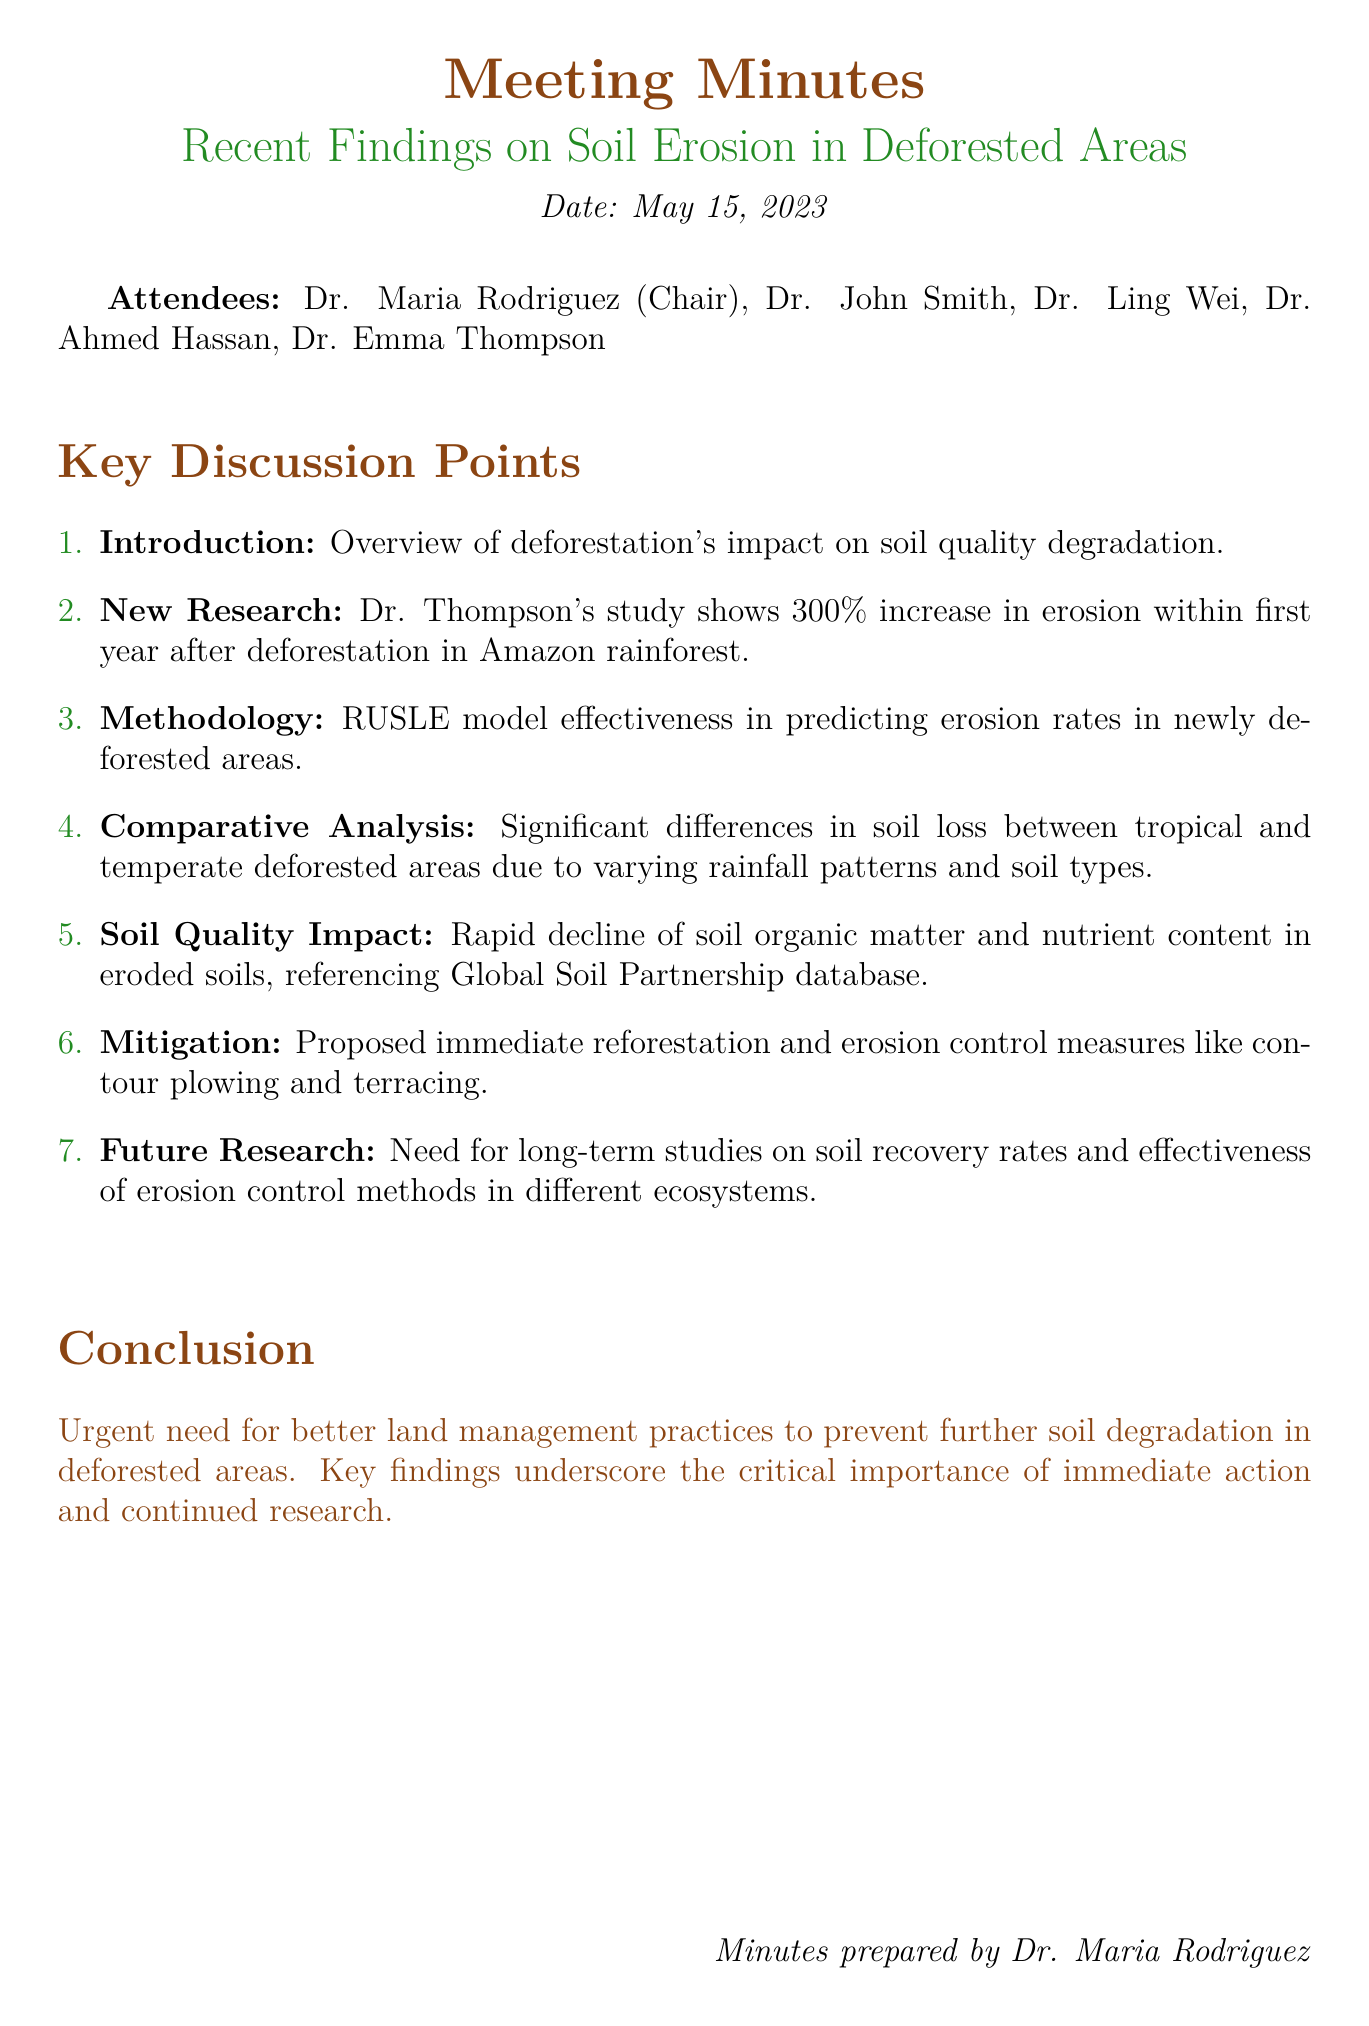What was the date of the meeting? The date of the meeting is clearly stated at the beginning of the document.
Answer: May 15, 2023 Who chaired the meeting? The document lists Dr. Maria Rodriguez as the chair of the meeting.
Answer: Dr. Maria Rodriguez What percentage increase in erosion was observed in the study? The document states that there was a 300% increase in erosion after deforestation.
Answer: 300% What model was discussed for predicting erosion rates? The RUSLE model is mentioned as the method used in Dr. Thompson's study.
Answer: RUSLE Which areas were compared in the erosion rates discussion? The document differentiates between tropical (Amazon) and temperate (North American) deforested areas.
Answer: Tropical and temperate What is one proposed mitigation strategy? The document mentions immediate reforestation as a proposed measure.
Answer: Immediate reforestation What did the discussion highlight regarding soil quality? There was a significant discussion on the rapid decline of soil organic matter in eroded soils.
Answer: Rapid decline of soil organic matter What is the urgent need emphasized in the conclusion? The conclusion stresses the need for better land management practices.
Answer: Better land management practices 